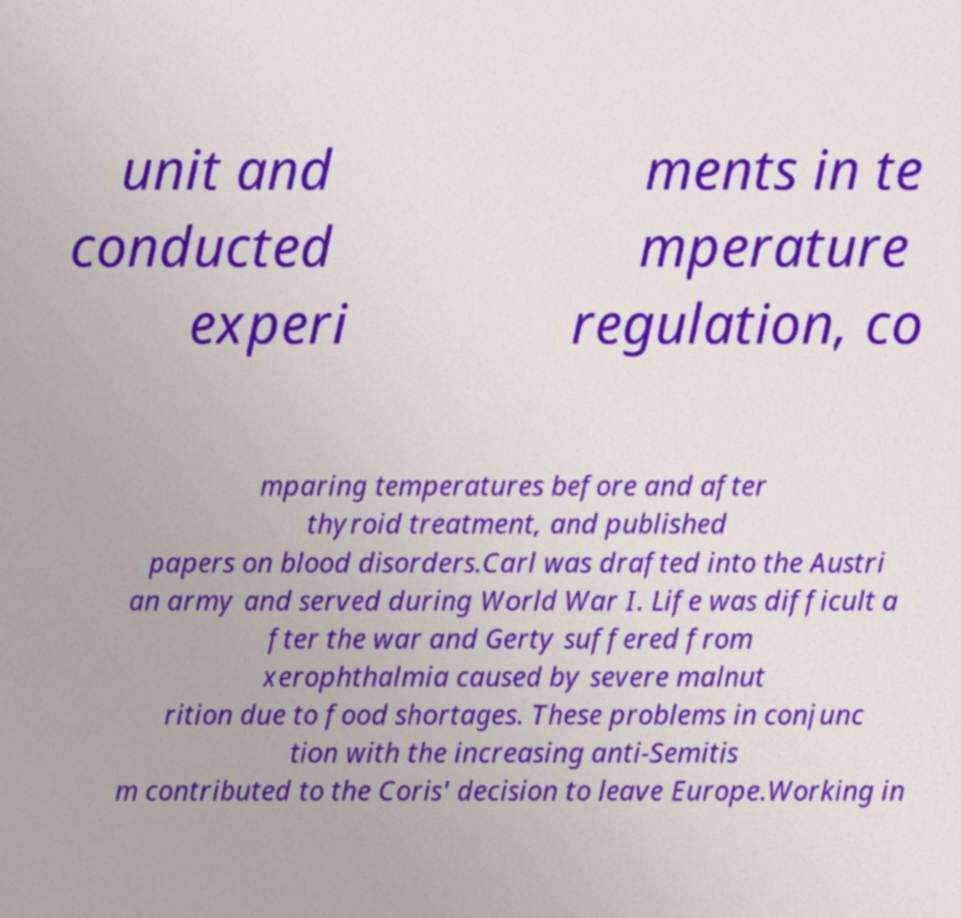There's text embedded in this image that I need extracted. Can you transcribe it verbatim? unit and conducted experi ments in te mperature regulation, co mparing temperatures before and after thyroid treatment, and published papers on blood disorders.Carl was drafted into the Austri an army and served during World War I. Life was difficult a fter the war and Gerty suffered from xerophthalmia caused by severe malnut rition due to food shortages. These problems in conjunc tion with the increasing anti-Semitis m contributed to the Coris' decision to leave Europe.Working in 